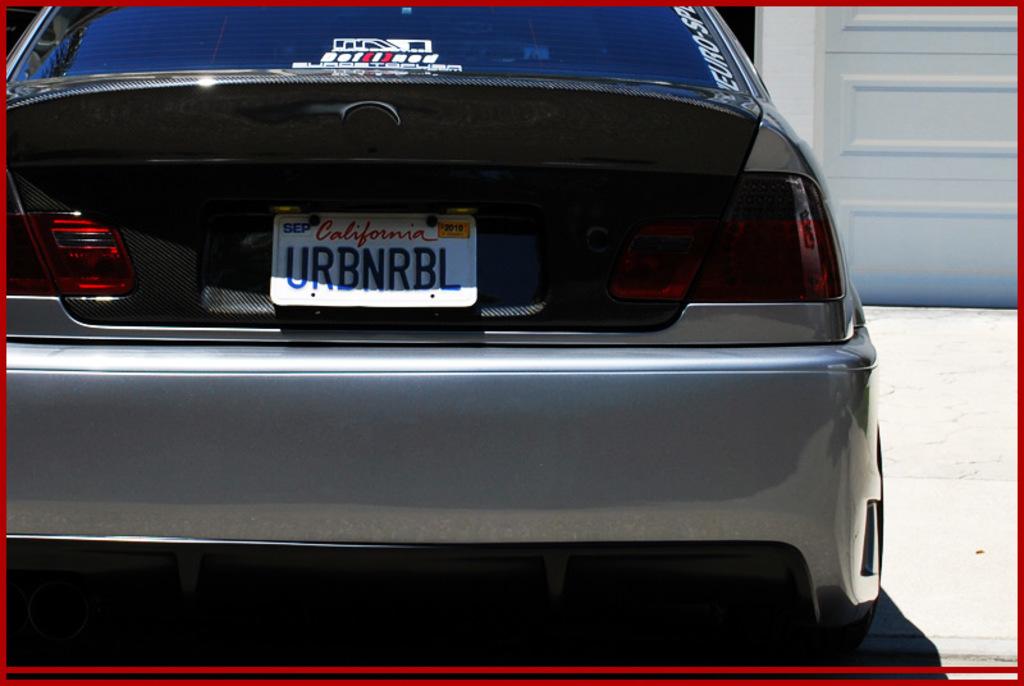What does the licence plate say?
Your response must be concise. Urbnrbl. What state was the license plate issued in?
Your response must be concise. California. 